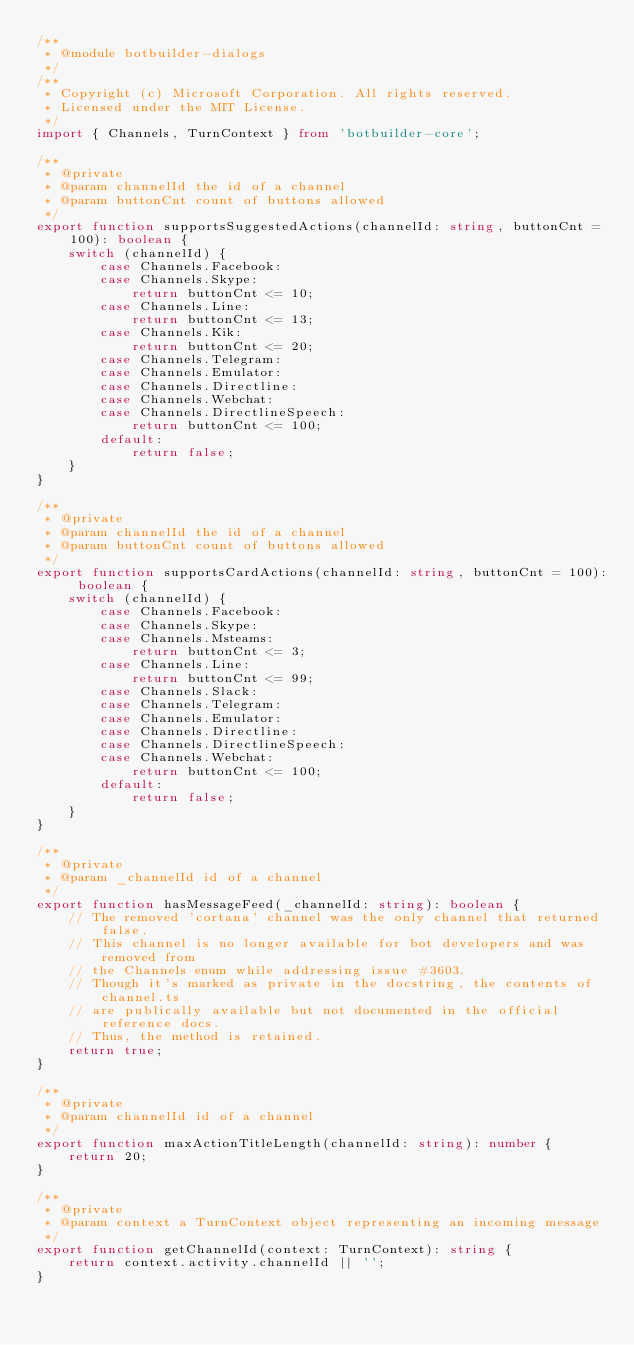Convert code to text. <code><loc_0><loc_0><loc_500><loc_500><_TypeScript_>/**
 * @module botbuilder-dialogs
 */
/**
 * Copyright (c) Microsoft Corporation. All rights reserved.
 * Licensed under the MIT License.
 */
import { Channels, TurnContext } from 'botbuilder-core';

/**
 * @private
 * @param channelId the id of a channel
 * @param buttonCnt count of buttons allowed
 */
export function supportsSuggestedActions(channelId: string, buttonCnt = 100): boolean {
    switch (channelId) {
        case Channels.Facebook:
        case Channels.Skype:
            return buttonCnt <= 10;
        case Channels.Line:
            return buttonCnt <= 13;
        case Channels.Kik:
            return buttonCnt <= 20;
        case Channels.Telegram:
        case Channels.Emulator:
        case Channels.Directline:
        case Channels.Webchat:
        case Channels.DirectlineSpeech:
            return buttonCnt <= 100;
        default:
            return false;
    }
}

/**
 * @private
 * @param channelId the id of a channel
 * @param buttonCnt count of buttons allowed
 */
export function supportsCardActions(channelId: string, buttonCnt = 100): boolean {
    switch (channelId) {
        case Channels.Facebook:
        case Channels.Skype:
        case Channels.Msteams:
            return buttonCnt <= 3;
        case Channels.Line:
            return buttonCnt <= 99;
        case Channels.Slack:
        case Channels.Telegram:
        case Channels.Emulator:
        case Channels.Directline:
        case Channels.DirectlineSpeech:
        case Channels.Webchat:
            return buttonCnt <= 100;
        default:
            return false;
    }
}

/**
 * @private
 * @param _channelId id of a channel
 */
export function hasMessageFeed(_channelId: string): boolean {
    // The removed 'cortana' channel was the only channel that returned false.
    // This channel is no longer available for bot developers and was removed from
    // the Channels enum while addressing issue #3603.
    // Though it's marked as private in the docstring, the contents of channel.ts
    // are publically available but not documented in the official reference docs.
    // Thus, the method is retained.
    return true;
}

/**
 * @private
 * @param channelId id of a channel
 */
export function maxActionTitleLength(channelId: string): number {
    return 20;
}

/**
 * @private
 * @param context a TurnContext object representing an incoming message
 */
export function getChannelId(context: TurnContext): string {
    return context.activity.channelId || '';
}
</code> 